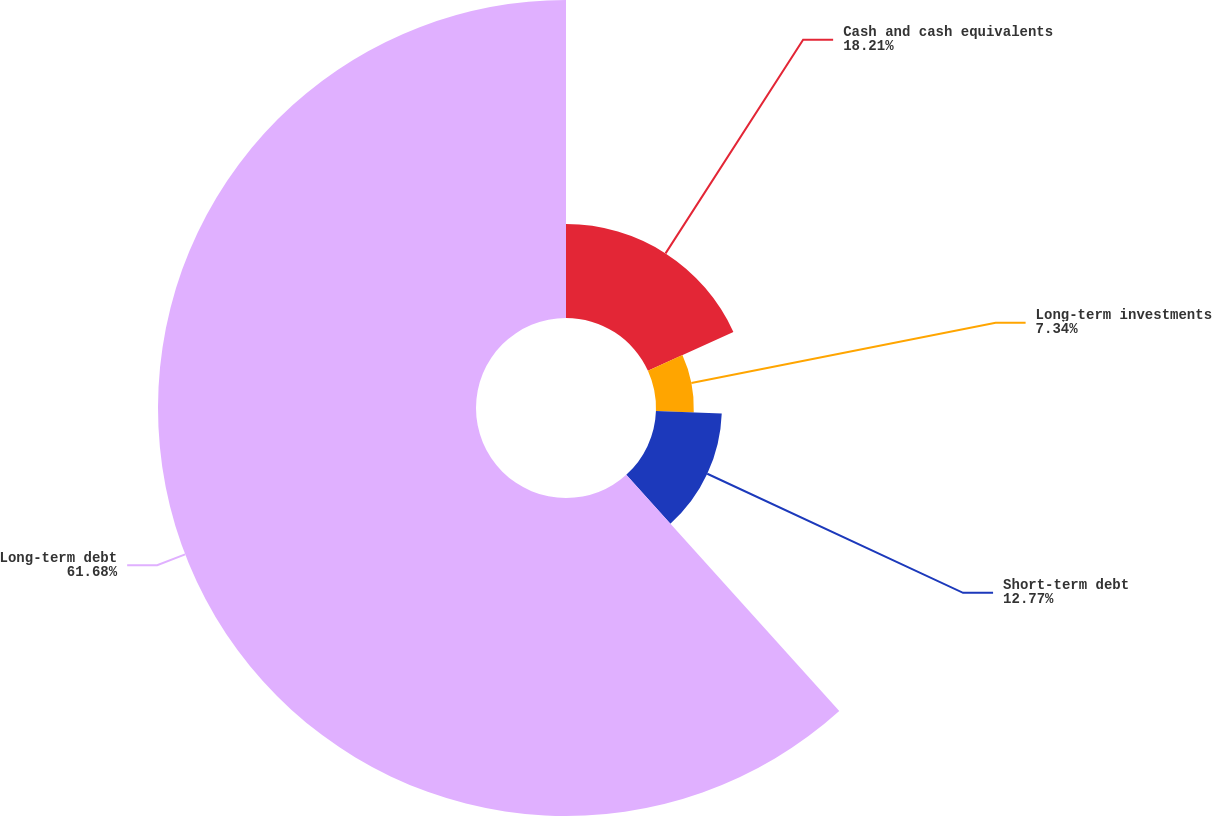Convert chart. <chart><loc_0><loc_0><loc_500><loc_500><pie_chart><fcel>Cash and cash equivalents<fcel>Long-term investments<fcel>Short-term debt<fcel>Long-term debt<nl><fcel>18.21%<fcel>7.34%<fcel>12.77%<fcel>61.68%<nl></chart> 